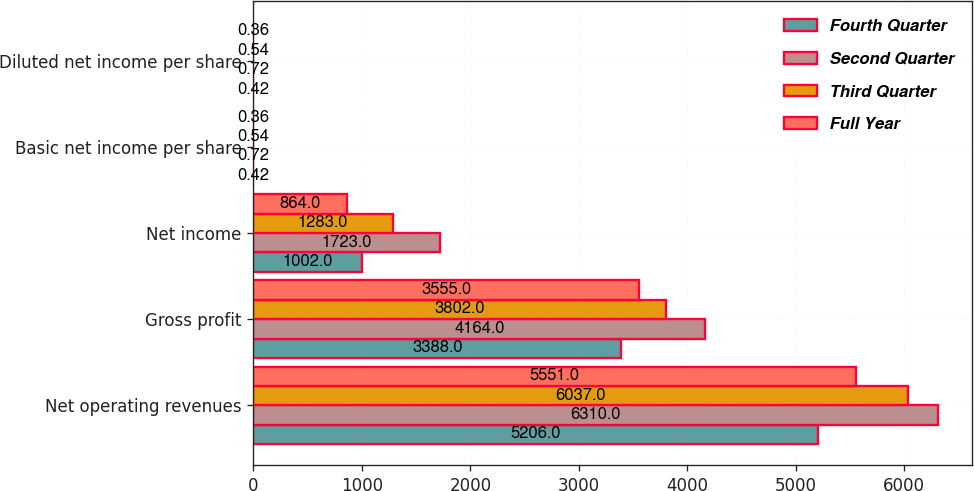Convert chart. <chart><loc_0><loc_0><loc_500><loc_500><stacked_bar_chart><ecel><fcel>Net operating revenues<fcel>Gross profit<fcel>Net income<fcel>Basic net income per share<fcel>Diluted net income per share<nl><fcel>Fourth Quarter<fcel>5206<fcel>3388<fcel>1002<fcel>0.42<fcel>0.42<nl><fcel>Second Quarter<fcel>6310<fcel>4164<fcel>1723<fcel>0.72<fcel>0.72<nl><fcel>Third Quarter<fcel>6037<fcel>3802<fcel>1283<fcel>0.54<fcel>0.54<nl><fcel>Full Year<fcel>5551<fcel>3555<fcel>864<fcel>0.36<fcel>0.36<nl></chart> 